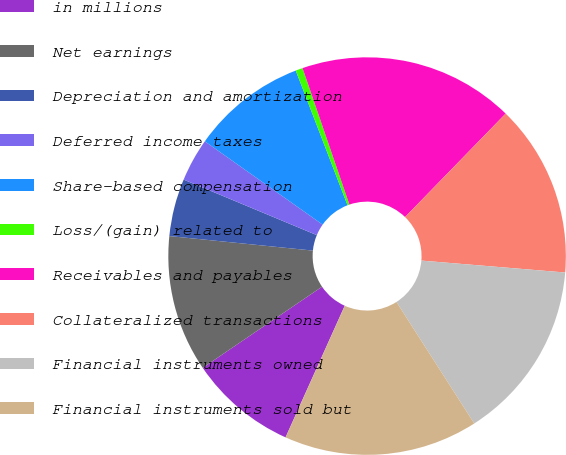<chart> <loc_0><loc_0><loc_500><loc_500><pie_chart><fcel>in millions<fcel>Net earnings<fcel>Depreciation and amortization<fcel>Deferred income taxes<fcel>Share-based compensation<fcel>Loss/(gain) related to<fcel>Receivables and payables<fcel>Collateralized transactions<fcel>Financial instruments owned<fcel>Financial instruments sold but<nl><fcel>8.77%<fcel>11.11%<fcel>4.68%<fcel>3.51%<fcel>9.36%<fcel>0.58%<fcel>17.54%<fcel>14.04%<fcel>14.62%<fcel>15.79%<nl></chart> 